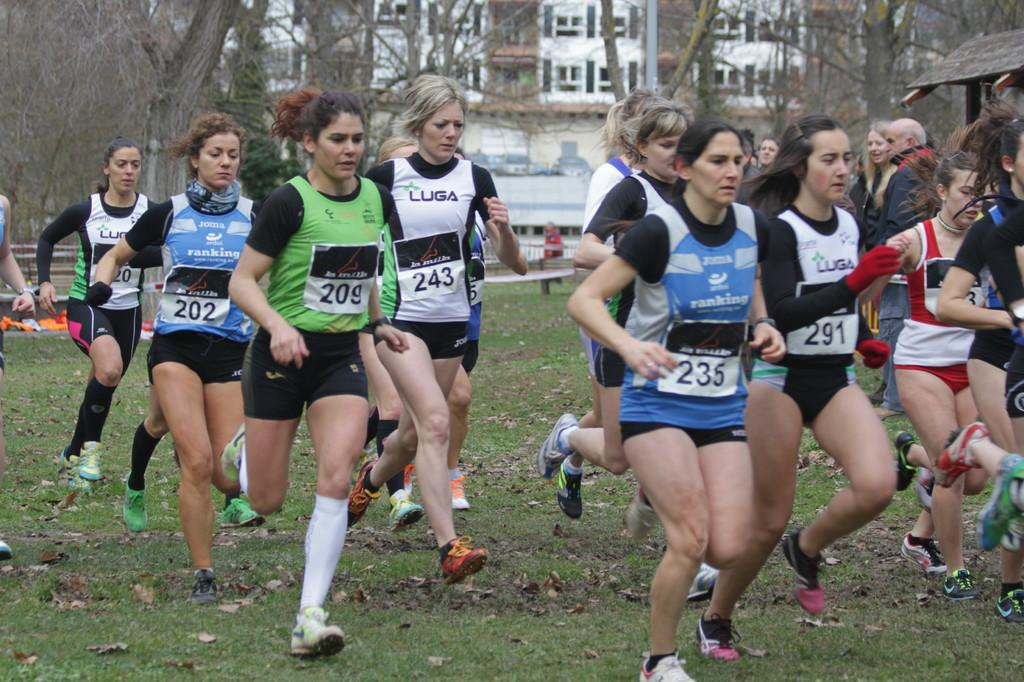<image>
Share a concise interpretation of the image provided. Runners in a race with one that has  tag which says 235. 